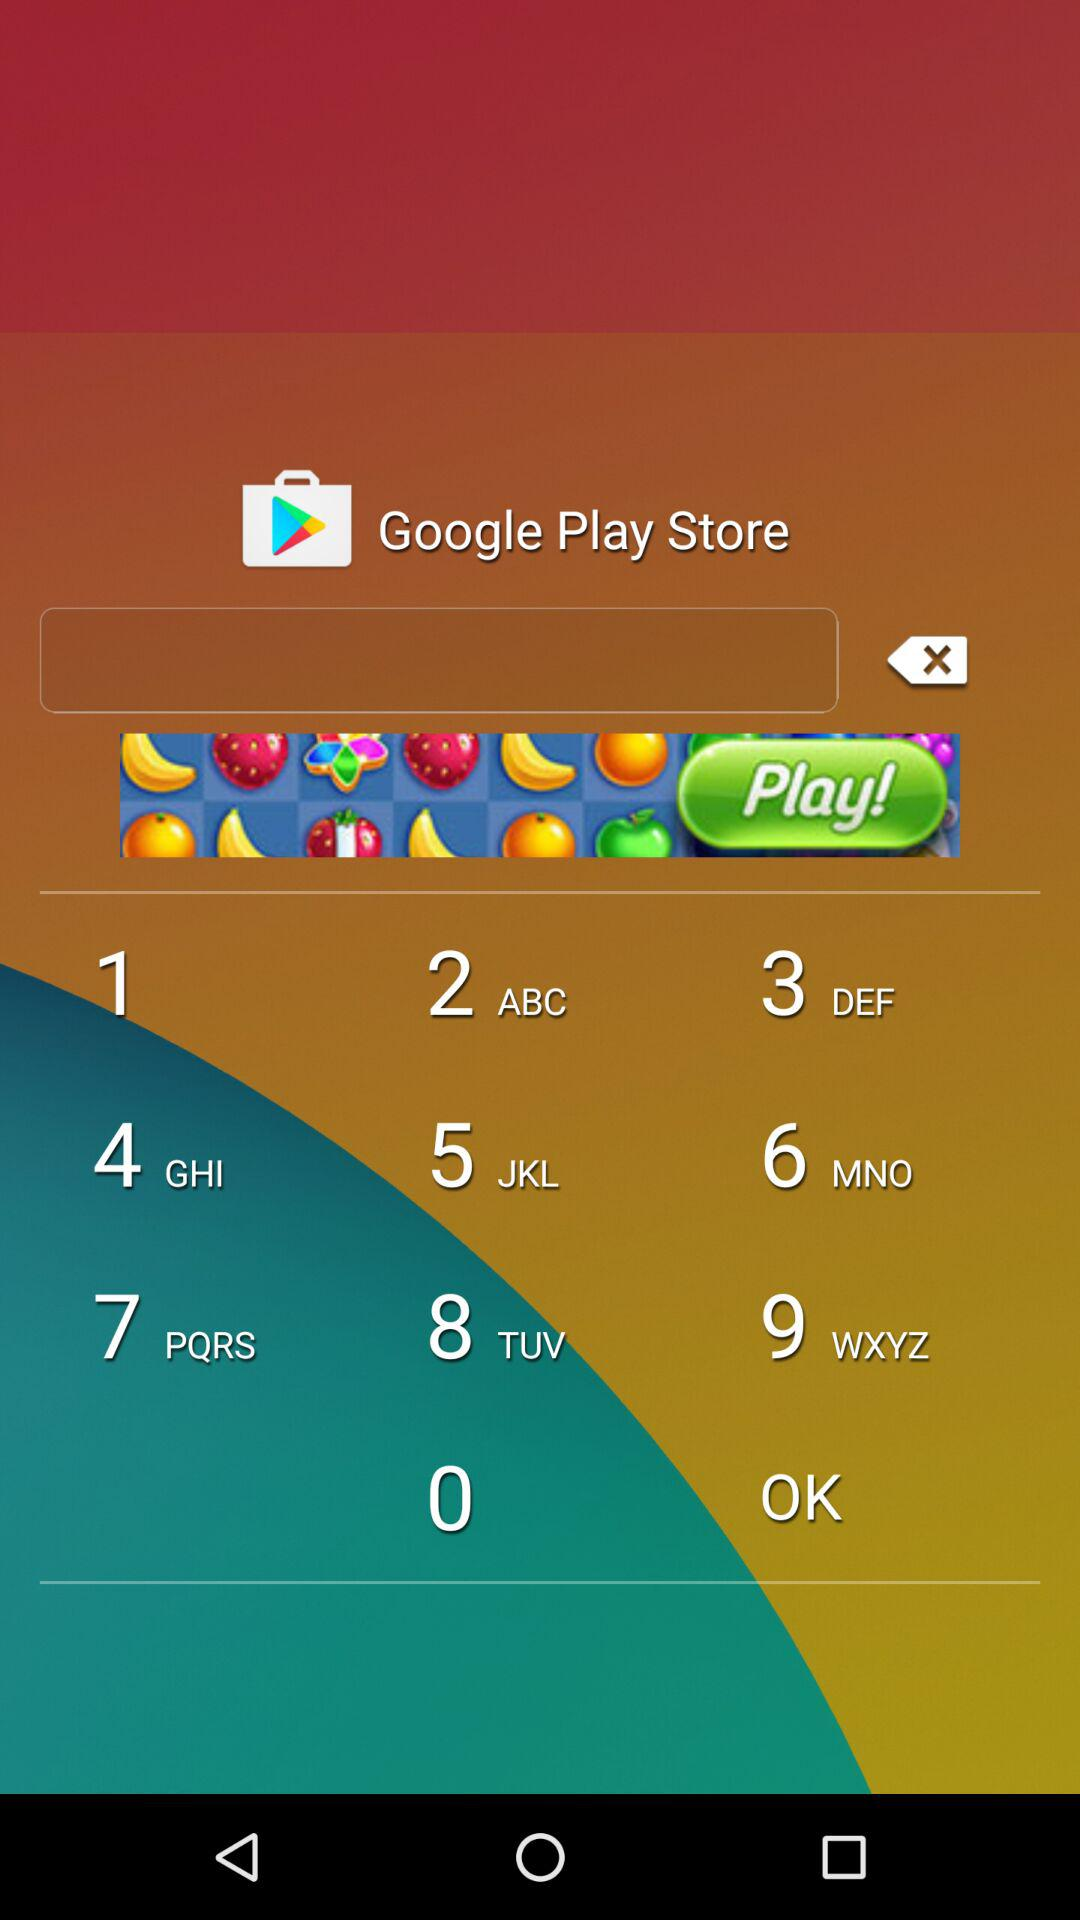What is the date of "1st day of LMP"? The date of "1st day of LMP" is March 17, 2017. 